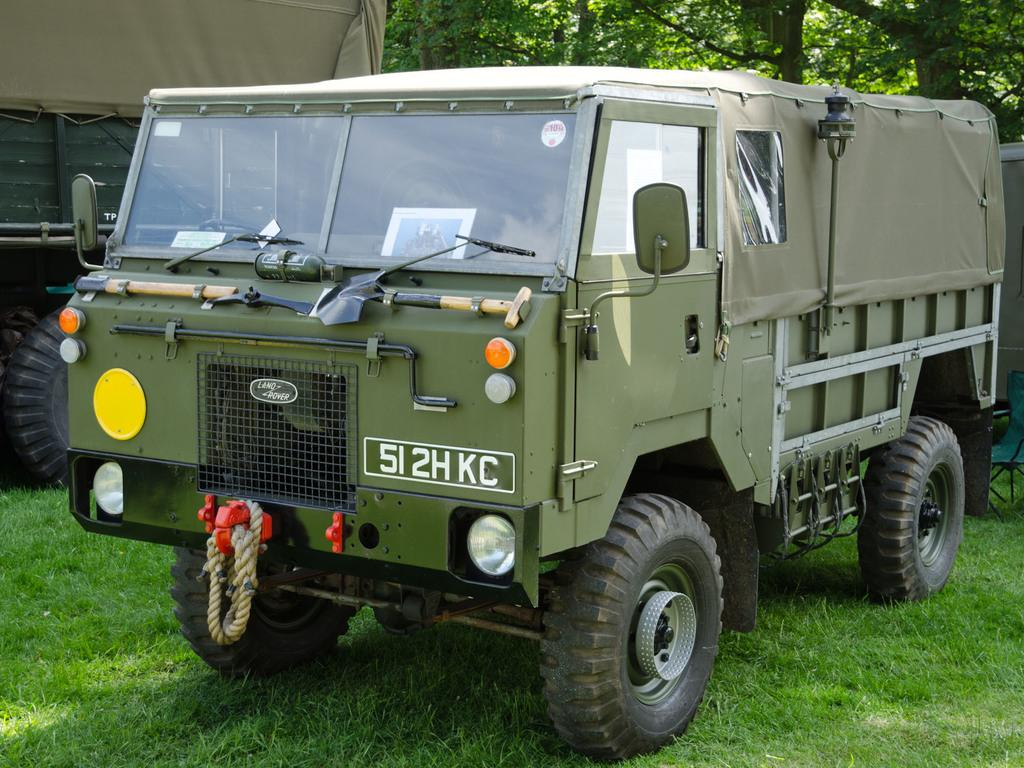What types of objects are visible on the ground in the image? There are two vehicles visible on the ground in the image. What can be seen in the background of the image? There are trees visible at the top of the image. What advice is the mom giving during the discussion in the image? There is no mom or discussion present in the image; it only features two vehicles and trees in the background. 